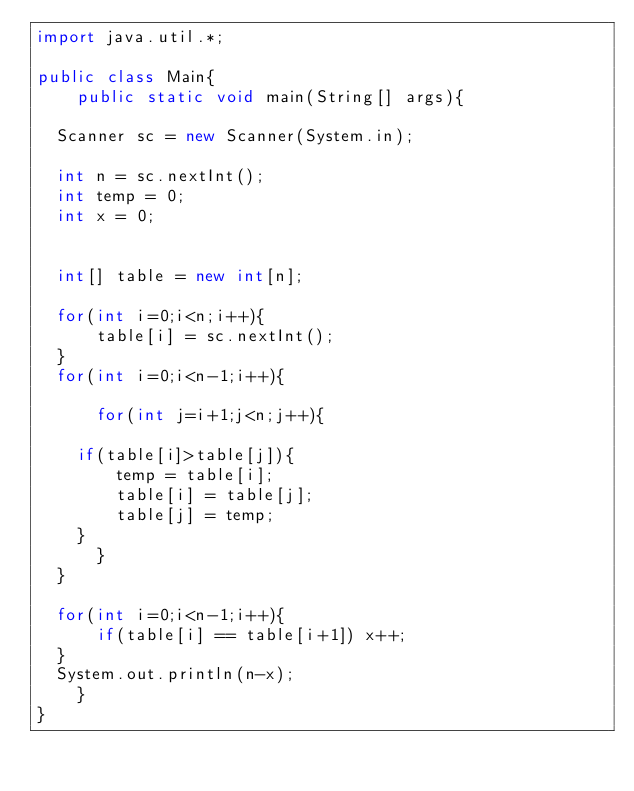Convert code to text. <code><loc_0><loc_0><loc_500><loc_500><_Java_>import java.util.*;

public class Main{
    public static void main(String[] args){

	Scanner sc = new Scanner(System.in);

	int n = sc.nextInt();
	int temp = 0;
	int x = 0;
	
	
	int[] table = new int[n];

	for(int i=0;i<n;i++){
	    table[i] = sc.nextInt();
	}
	for(int i=0;i<n-1;i++){
	    
	    for(int j=i+1;j<n;j++){
		
		if(table[i]>table[j]){
		    temp = table[i];
		    table[i] = table[j];
		    table[j] = temp;
		}
	    }
	}

	for(int i=0;i<n-1;i++){
	    if(table[i] == table[i+1]) x++;
	}
	System.out.println(n-x);
    }
}
</code> 